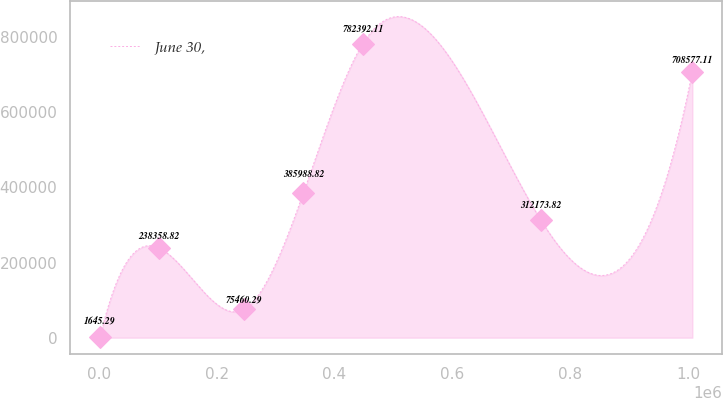Convert chart to OTSL. <chart><loc_0><loc_0><loc_500><loc_500><line_chart><ecel><fcel>June 30,<nl><fcel>2015.03<fcel>1645.29<nl><fcel>102581<fcel>238359<nl><fcel>246750<fcel>75460.3<nl><fcel>347316<fcel>385989<nl><fcel>447883<fcel>782392<nl><fcel>750728<fcel>312174<nl><fcel>1.00768e+06<fcel>708577<nl></chart> 